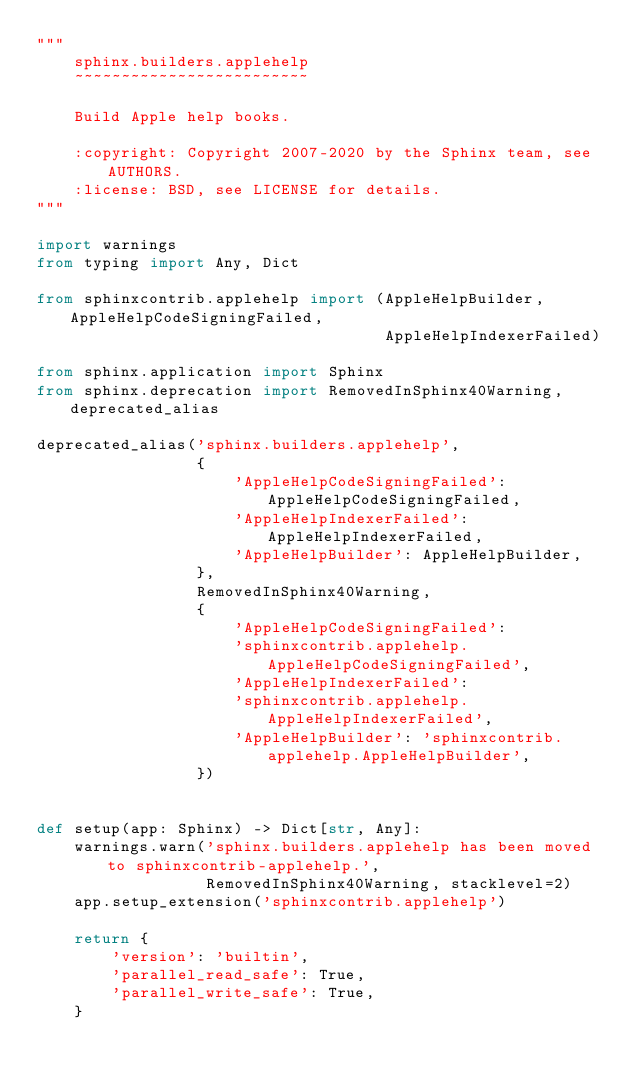Convert code to text. <code><loc_0><loc_0><loc_500><loc_500><_Python_>"""
    sphinx.builders.applehelp
    ~~~~~~~~~~~~~~~~~~~~~~~~~

    Build Apple help books.

    :copyright: Copyright 2007-2020 by the Sphinx team, see AUTHORS.
    :license: BSD, see LICENSE for details.
"""

import warnings
from typing import Any, Dict

from sphinxcontrib.applehelp import (AppleHelpBuilder, AppleHelpCodeSigningFailed,
                                     AppleHelpIndexerFailed)

from sphinx.application import Sphinx
from sphinx.deprecation import RemovedInSphinx40Warning, deprecated_alias

deprecated_alias('sphinx.builders.applehelp',
                 {
                     'AppleHelpCodeSigningFailed': AppleHelpCodeSigningFailed,
                     'AppleHelpIndexerFailed': AppleHelpIndexerFailed,
                     'AppleHelpBuilder': AppleHelpBuilder,
                 },
                 RemovedInSphinx40Warning,
                 {
                     'AppleHelpCodeSigningFailed':
                     'sphinxcontrib.applehelp.AppleHelpCodeSigningFailed',
                     'AppleHelpIndexerFailed':
                     'sphinxcontrib.applehelp.AppleHelpIndexerFailed',
                     'AppleHelpBuilder': 'sphinxcontrib.applehelp.AppleHelpBuilder',
                 })


def setup(app: Sphinx) -> Dict[str, Any]:
    warnings.warn('sphinx.builders.applehelp has been moved to sphinxcontrib-applehelp.',
                  RemovedInSphinx40Warning, stacklevel=2)
    app.setup_extension('sphinxcontrib.applehelp')

    return {
        'version': 'builtin',
        'parallel_read_safe': True,
        'parallel_write_safe': True,
    }
</code> 